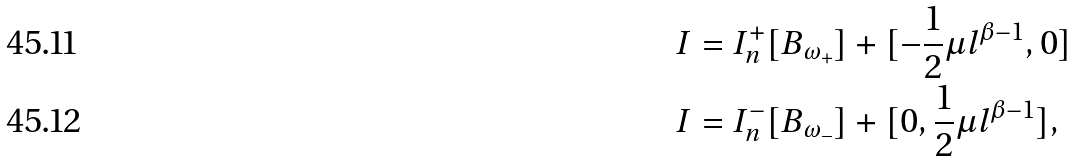<formula> <loc_0><loc_0><loc_500><loc_500>I & = I _ { n } ^ { + } [ B _ { \omega _ { + } } ] + [ - \frac { 1 } { 2 } \mu l ^ { \beta - 1 } , 0 ] \\ I & = I _ { n } ^ { - } [ B _ { \omega _ { - } } ] + [ 0 , \frac { 1 } { 2 } \mu l ^ { \beta - 1 } ] ,</formula> 